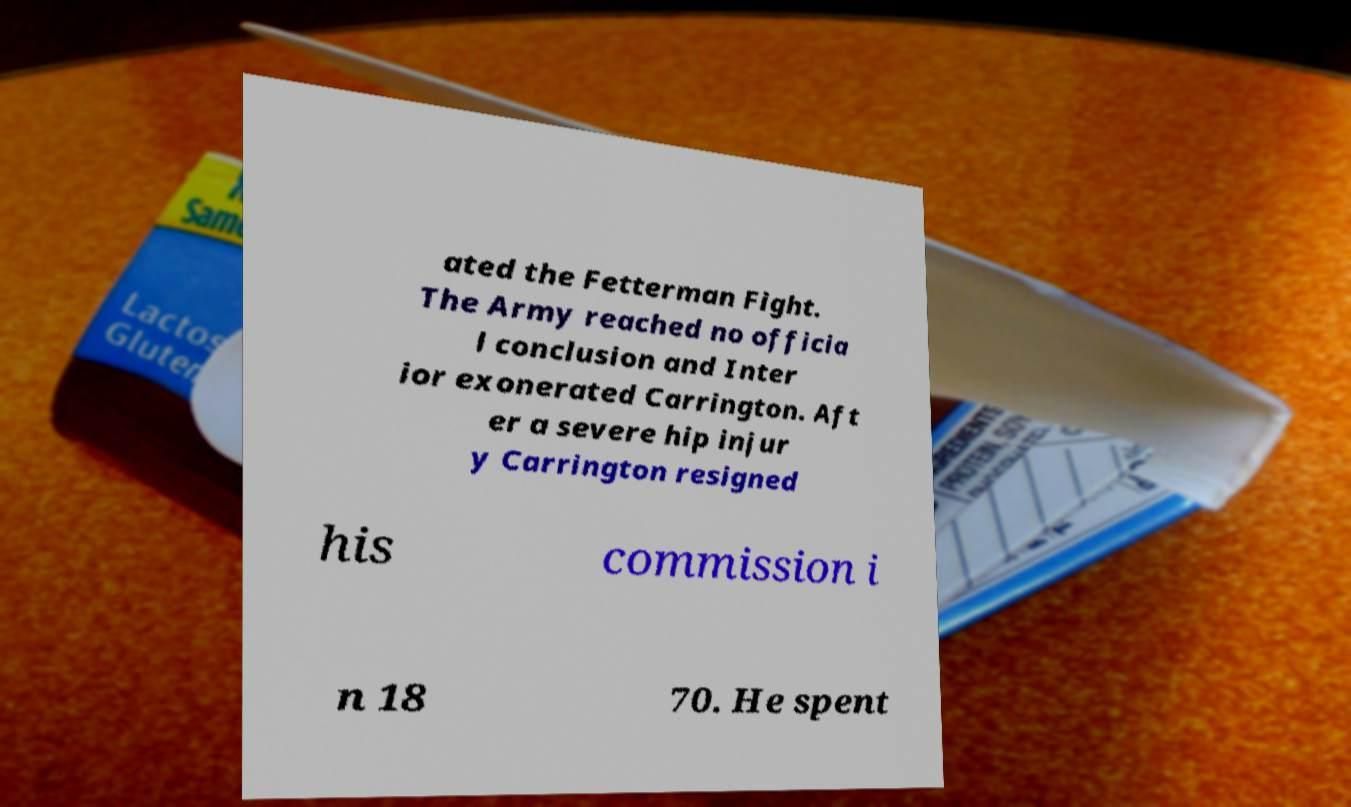Could you assist in decoding the text presented in this image and type it out clearly? ated the Fetterman Fight. The Army reached no officia l conclusion and Inter ior exonerated Carrington. Aft er a severe hip injur y Carrington resigned his commission i n 18 70. He spent 